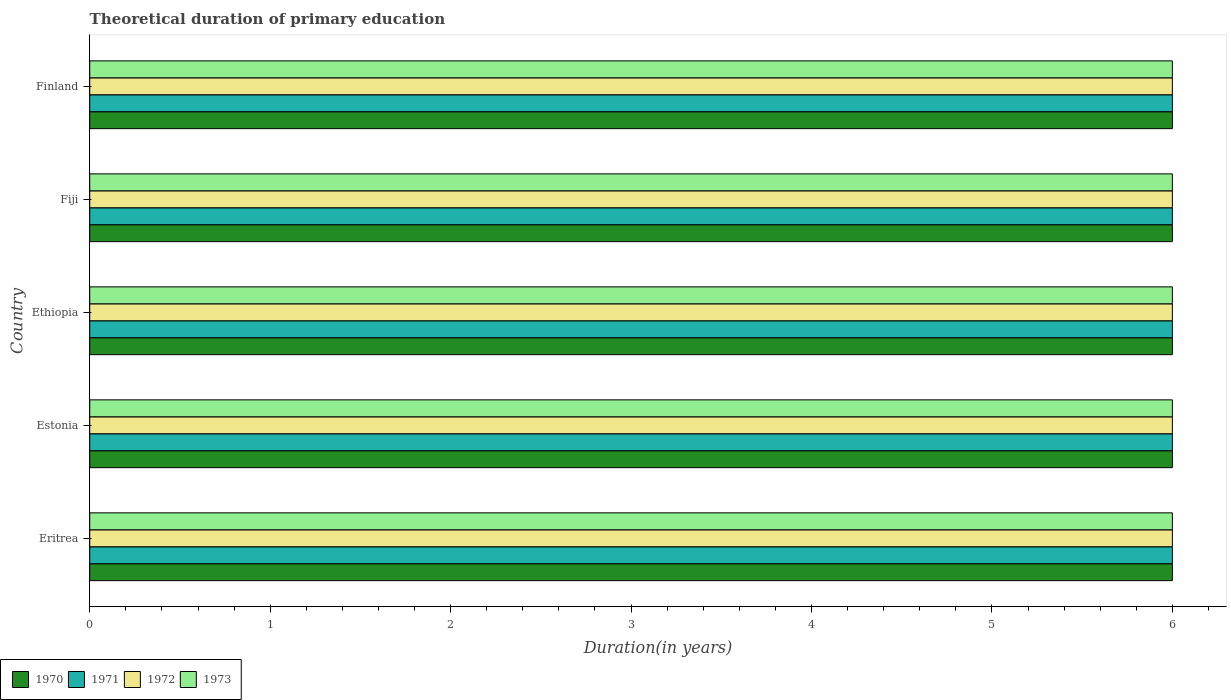How many different coloured bars are there?
Your answer should be compact. 4. How many groups of bars are there?
Ensure brevity in your answer.  5. Are the number of bars on each tick of the Y-axis equal?
Give a very brief answer. Yes. What is the label of the 3rd group of bars from the top?
Offer a very short reply. Ethiopia. Across all countries, what is the minimum total theoretical duration of primary education in 1971?
Keep it short and to the point. 6. In which country was the total theoretical duration of primary education in 1971 maximum?
Provide a short and direct response. Eritrea. In which country was the total theoretical duration of primary education in 1972 minimum?
Provide a short and direct response. Eritrea. What is the total total theoretical duration of primary education in 1972 in the graph?
Ensure brevity in your answer.  30. What is the difference between the total theoretical duration of primary education in 1973 in Eritrea and that in Finland?
Your answer should be compact. 0. In how many countries, is the total theoretical duration of primary education in 1973 greater than 4.2 years?
Provide a succinct answer. 5. Is the total theoretical duration of primary education in 1972 in Eritrea less than that in Ethiopia?
Offer a terse response. No. Is the difference between the total theoretical duration of primary education in 1973 in Estonia and Fiji greater than the difference between the total theoretical duration of primary education in 1970 in Estonia and Fiji?
Make the answer very short. No. What is the difference between the highest and the lowest total theoretical duration of primary education in 1970?
Provide a succinct answer. 0. In how many countries, is the total theoretical duration of primary education in 1973 greater than the average total theoretical duration of primary education in 1973 taken over all countries?
Offer a very short reply. 0. Is the sum of the total theoretical duration of primary education in 1972 in Ethiopia and Fiji greater than the maximum total theoretical duration of primary education in 1971 across all countries?
Provide a short and direct response. Yes. Is it the case that in every country, the sum of the total theoretical duration of primary education in 1972 and total theoretical duration of primary education in 1971 is greater than the sum of total theoretical duration of primary education in 1973 and total theoretical duration of primary education in 1970?
Make the answer very short. No. Is it the case that in every country, the sum of the total theoretical duration of primary education in 1972 and total theoretical duration of primary education in 1971 is greater than the total theoretical duration of primary education in 1973?
Offer a very short reply. Yes. Are all the bars in the graph horizontal?
Your response must be concise. Yes. How many countries are there in the graph?
Provide a short and direct response. 5. Are the values on the major ticks of X-axis written in scientific E-notation?
Make the answer very short. No. Does the graph contain any zero values?
Offer a very short reply. No. How many legend labels are there?
Keep it short and to the point. 4. How are the legend labels stacked?
Give a very brief answer. Horizontal. What is the title of the graph?
Make the answer very short. Theoretical duration of primary education. Does "1965" appear as one of the legend labels in the graph?
Ensure brevity in your answer.  No. What is the label or title of the X-axis?
Ensure brevity in your answer.  Duration(in years). What is the label or title of the Y-axis?
Provide a succinct answer. Country. What is the Duration(in years) of 1971 in Eritrea?
Offer a very short reply. 6. What is the Duration(in years) of 1972 in Eritrea?
Keep it short and to the point. 6. What is the Duration(in years) of 1973 in Eritrea?
Keep it short and to the point. 6. What is the Duration(in years) in 1970 in Estonia?
Keep it short and to the point. 6. What is the Duration(in years) in 1972 in Estonia?
Your answer should be compact. 6. What is the Duration(in years) in 1973 in Estonia?
Make the answer very short. 6. What is the Duration(in years) of 1970 in Ethiopia?
Provide a short and direct response. 6. What is the Duration(in years) of 1970 in Fiji?
Make the answer very short. 6. What is the Duration(in years) of 1973 in Fiji?
Offer a terse response. 6. What is the Duration(in years) in 1970 in Finland?
Your response must be concise. 6. What is the Duration(in years) in 1972 in Finland?
Provide a short and direct response. 6. Across all countries, what is the maximum Duration(in years) of 1972?
Your answer should be compact. 6. Across all countries, what is the minimum Duration(in years) of 1971?
Provide a short and direct response. 6. Across all countries, what is the minimum Duration(in years) of 1972?
Your answer should be compact. 6. Across all countries, what is the minimum Duration(in years) of 1973?
Your answer should be compact. 6. What is the total Duration(in years) in 1970 in the graph?
Offer a terse response. 30. What is the total Duration(in years) of 1972 in the graph?
Your answer should be very brief. 30. What is the total Duration(in years) of 1973 in the graph?
Your answer should be very brief. 30. What is the difference between the Duration(in years) of 1970 in Eritrea and that in Estonia?
Make the answer very short. 0. What is the difference between the Duration(in years) of 1972 in Eritrea and that in Estonia?
Make the answer very short. 0. What is the difference between the Duration(in years) of 1973 in Eritrea and that in Estonia?
Your answer should be very brief. 0. What is the difference between the Duration(in years) in 1970 in Eritrea and that in Ethiopia?
Give a very brief answer. 0. What is the difference between the Duration(in years) in 1972 in Eritrea and that in Ethiopia?
Make the answer very short. 0. What is the difference between the Duration(in years) of 1971 in Eritrea and that in Fiji?
Your answer should be compact. 0. What is the difference between the Duration(in years) in 1973 in Eritrea and that in Fiji?
Give a very brief answer. 0. What is the difference between the Duration(in years) in 1971 in Eritrea and that in Finland?
Ensure brevity in your answer.  0. What is the difference between the Duration(in years) in 1972 in Eritrea and that in Finland?
Your response must be concise. 0. What is the difference between the Duration(in years) in 1970 in Estonia and that in Ethiopia?
Offer a very short reply. 0. What is the difference between the Duration(in years) of 1973 in Estonia and that in Ethiopia?
Provide a short and direct response. 0. What is the difference between the Duration(in years) in 1970 in Estonia and that in Fiji?
Give a very brief answer. 0. What is the difference between the Duration(in years) in 1972 in Estonia and that in Fiji?
Give a very brief answer. 0. What is the difference between the Duration(in years) of 1973 in Estonia and that in Finland?
Give a very brief answer. 0. What is the difference between the Duration(in years) in 1970 in Ethiopia and that in Finland?
Your answer should be compact. 0. What is the difference between the Duration(in years) in 1972 in Ethiopia and that in Finland?
Give a very brief answer. 0. What is the difference between the Duration(in years) in 1973 in Ethiopia and that in Finland?
Provide a succinct answer. 0. What is the difference between the Duration(in years) in 1970 in Fiji and that in Finland?
Your response must be concise. 0. What is the difference between the Duration(in years) of 1972 in Fiji and that in Finland?
Your response must be concise. 0. What is the difference between the Duration(in years) of 1973 in Fiji and that in Finland?
Offer a very short reply. 0. What is the difference between the Duration(in years) in 1970 in Eritrea and the Duration(in years) in 1971 in Estonia?
Your answer should be compact. 0. What is the difference between the Duration(in years) in 1970 in Eritrea and the Duration(in years) in 1972 in Estonia?
Make the answer very short. 0. What is the difference between the Duration(in years) in 1971 in Eritrea and the Duration(in years) in 1972 in Estonia?
Offer a terse response. 0. What is the difference between the Duration(in years) in 1970 in Eritrea and the Duration(in years) in 1971 in Ethiopia?
Provide a succinct answer. 0. What is the difference between the Duration(in years) of 1970 in Eritrea and the Duration(in years) of 1973 in Ethiopia?
Provide a short and direct response. 0. What is the difference between the Duration(in years) of 1971 in Eritrea and the Duration(in years) of 1972 in Fiji?
Your answer should be very brief. 0. What is the difference between the Duration(in years) of 1971 in Eritrea and the Duration(in years) of 1973 in Fiji?
Your answer should be compact. 0. What is the difference between the Duration(in years) of 1972 in Eritrea and the Duration(in years) of 1973 in Fiji?
Offer a terse response. 0. What is the difference between the Duration(in years) in 1970 in Eritrea and the Duration(in years) in 1971 in Finland?
Provide a succinct answer. 0. What is the difference between the Duration(in years) of 1970 in Eritrea and the Duration(in years) of 1973 in Finland?
Offer a very short reply. 0. What is the difference between the Duration(in years) in 1971 in Eritrea and the Duration(in years) in 1973 in Finland?
Offer a very short reply. 0. What is the difference between the Duration(in years) of 1970 in Estonia and the Duration(in years) of 1971 in Ethiopia?
Provide a succinct answer. 0. What is the difference between the Duration(in years) of 1970 in Estonia and the Duration(in years) of 1972 in Ethiopia?
Provide a short and direct response. 0. What is the difference between the Duration(in years) of 1970 in Estonia and the Duration(in years) of 1973 in Ethiopia?
Ensure brevity in your answer.  0. What is the difference between the Duration(in years) of 1971 in Estonia and the Duration(in years) of 1972 in Ethiopia?
Your answer should be very brief. 0. What is the difference between the Duration(in years) in 1971 in Estonia and the Duration(in years) in 1973 in Ethiopia?
Your answer should be compact. 0. What is the difference between the Duration(in years) of 1972 in Estonia and the Duration(in years) of 1973 in Ethiopia?
Keep it short and to the point. 0. What is the difference between the Duration(in years) in 1970 in Estonia and the Duration(in years) in 1973 in Fiji?
Your answer should be compact. 0. What is the difference between the Duration(in years) in 1970 in Estonia and the Duration(in years) in 1972 in Finland?
Ensure brevity in your answer.  0. What is the difference between the Duration(in years) of 1970 in Estonia and the Duration(in years) of 1973 in Finland?
Make the answer very short. 0. What is the difference between the Duration(in years) of 1971 in Estonia and the Duration(in years) of 1972 in Finland?
Give a very brief answer. 0. What is the difference between the Duration(in years) in 1970 in Ethiopia and the Duration(in years) in 1973 in Fiji?
Your answer should be very brief. 0. What is the difference between the Duration(in years) in 1971 in Ethiopia and the Duration(in years) in 1973 in Fiji?
Your response must be concise. 0. What is the difference between the Duration(in years) of 1972 in Ethiopia and the Duration(in years) of 1973 in Fiji?
Ensure brevity in your answer.  0. What is the difference between the Duration(in years) of 1971 in Ethiopia and the Duration(in years) of 1972 in Finland?
Ensure brevity in your answer.  0. What is the difference between the Duration(in years) in 1971 in Ethiopia and the Duration(in years) in 1973 in Finland?
Give a very brief answer. 0. What is the difference between the Duration(in years) in 1972 in Ethiopia and the Duration(in years) in 1973 in Finland?
Give a very brief answer. 0. What is the difference between the Duration(in years) of 1970 in Fiji and the Duration(in years) of 1971 in Finland?
Give a very brief answer. 0. What is the difference between the Duration(in years) of 1970 in Fiji and the Duration(in years) of 1973 in Finland?
Give a very brief answer. 0. What is the difference between the Duration(in years) of 1971 in Fiji and the Duration(in years) of 1972 in Finland?
Keep it short and to the point. 0. What is the average Duration(in years) in 1970 per country?
Give a very brief answer. 6. What is the average Duration(in years) in 1971 per country?
Give a very brief answer. 6. What is the average Duration(in years) in 1972 per country?
Provide a succinct answer. 6. What is the average Duration(in years) in 1973 per country?
Offer a terse response. 6. What is the difference between the Duration(in years) of 1971 and Duration(in years) of 1972 in Eritrea?
Make the answer very short. 0. What is the difference between the Duration(in years) of 1971 and Duration(in years) of 1973 in Eritrea?
Your answer should be compact. 0. What is the difference between the Duration(in years) in 1972 and Duration(in years) in 1973 in Eritrea?
Keep it short and to the point. 0. What is the difference between the Duration(in years) in 1970 and Duration(in years) in 1972 in Estonia?
Provide a short and direct response. 0. What is the difference between the Duration(in years) of 1970 and Duration(in years) of 1973 in Estonia?
Your answer should be compact. 0. What is the difference between the Duration(in years) of 1971 and Duration(in years) of 1973 in Estonia?
Ensure brevity in your answer.  0. What is the difference between the Duration(in years) in 1970 and Duration(in years) in 1972 in Ethiopia?
Give a very brief answer. 0. What is the difference between the Duration(in years) of 1970 and Duration(in years) of 1973 in Ethiopia?
Provide a short and direct response. 0. What is the difference between the Duration(in years) of 1971 and Duration(in years) of 1972 in Ethiopia?
Ensure brevity in your answer.  0. What is the difference between the Duration(in years) in 1972 and Duration(in years) in 1973 in Ethiopia?
Give a very brief answer. 0. What is the difference between the Duration(in years) of 1970 and Duration(in years) of 1972 in Fiji?
Give a very brief answer. 0. What is the difference between the Duration(in years) of 1971 and Duration(in years) of 1972 in Fiji?
Your answer should be very brief. 0. What is the difference between the Duration(in years) in 1971 and Duration(in years) in 1973 in Fiji?
Offer a terse response. 0. What is the difference between the Duration(in years) in 1972 and Duration(in years) in 1973 in Fiji?
Ensure brevity in your answer.  0. What is the difference between the Duration(in years) in 1970 and Duration(in years) in 1971 in Finland?
Give a very brief answer. 0. What is the difference between the Duration(in years) of 1970 and Duration(in years) of 1973 in Finland?
Offer a very short reply. 0. What is the difference between the Duration(in years) in 1972 and Duration(in years) in 1973 in Finland?
Provide a short and direct response. 0. What is the ratio of the Duration(in years) in 1971 in Eritrea to that in Estonia?
Your answer should be compact. 1. What is the ratio of the Duration(in years) in 1973 in Eritrea to that in Estonia?
Provide a short and direct response. 1. What is the ratio of the Duration(in years) in 1972 in Eritrea to that in Ethiopia?
Your answer should be very brief. 1. What is the ratio of the Duration(in years) in 1973 in Eritrea to that in Ethiopia?
Offer a terse response. 1. What is the ratio of the Duration(in years) of 1971 in Eritrea to that in Fiji?
Ensure brevity in your answer.  1. What is the ratio of the Duration(in years) of 1970 in Eritrea to that in Finland?
Provide a short and direct response. 1. What is the ratio of the Duration(in years) in 1971 in Eritrea to that in Finland?
Your response must be concise. 1. What is the ratio of the Duration(in years) of 1970 in Estonia to that in Ethiopia?
Give a very brief answer. 1. What is the ratio of the Duration(in years) of 1972 in Estonia to that in Ethiopia?
Provide a short and direct response. 1. What is the ratio of the Duration(in years) in 1973 in Estonia to that in Ethiopia?
Offer a terse response. 1. What is the ratio of the Duration(in years) in 1971 in Estonia to that in Fiji?
Give a very brief answer. 1. What is the ratio of the Duration(in years) of 1973 in Estonia to that in Fiji?
Provide a succinct answer. 1. What is the ratio of the Duration(in years) in 1970 in Estonia to that in Finland?
Ensure brevity in your answer.  1. What is the ratio of the Duration(in years) of 1971 in Estonia to that in Finland?
Provide a succinct answer. 1. What is the ratio of the Duration(in years) of 1972 in Estonia to that in Finland?
Make the answer very short. 1. What is the ratio of the Duration(in years) in 1973 in Estonia to that in Finland?
Provide a succinct answer. 1. What is the ratio of the Duration(in years) of 1970 in Ethiopia to that in Fiji?
Give a very brief answer. 1. What is the ratio of the Duration(in years) in 1972 in Ethiopia to that in Fiji?
Provide a succinct answer. 1. What is the ratio of the Duration(in years) in 1971 in Ethiopia to that in Finland?
Offer a terse response. 1. What is the ratio of the Duration(in years) in 1973 in Ethiopia to that in Finland?
Give a very brief answer. 1. What is the difference between the highest and the second highest Duration(in years) of 1970?
Provide a short and direct response. 0. What is the difference between the highest and the second highest Duration(in years) of 1971?
Make the answer very short. 0. What is the difference between the highest and the second highest Duration(in years) in 1972?
Your answer should be compact. 0. What is the difference between the highest and the second highest Duration(in years) in 1973?
Make the answer very short. 0. What is the difference between the highest and the lowest Duration(in years) in 1970?
Provide a short and direct response. 0. What is the difference between the highest and the lowest Duration(in years) in 1971?
Your response must be concise. 0. What is the difference between the highest and the lowest Duration(in years) of 1973?
Keep it short and to the point. 0. 